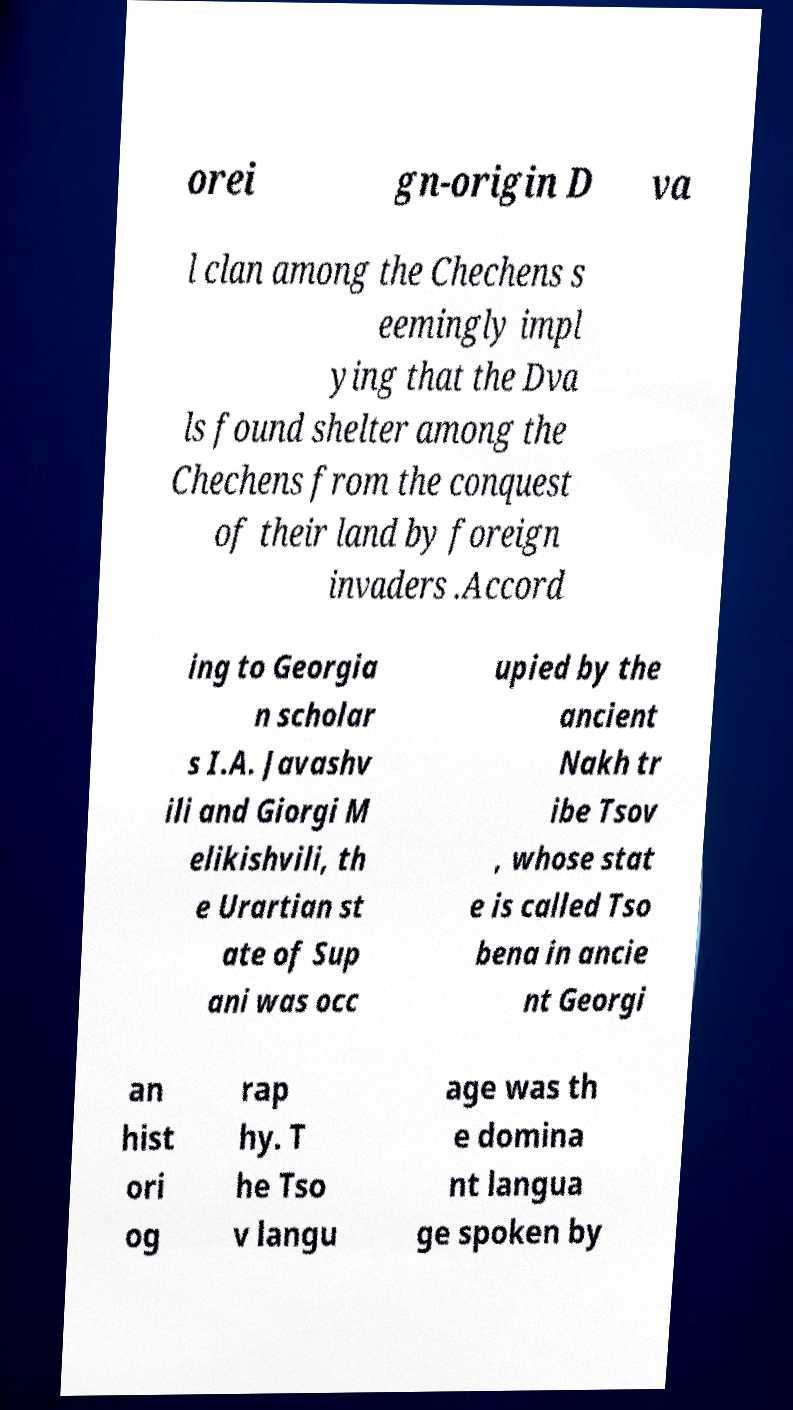Could you extract and type out the text from this image? orei gn-origin D va l clan among the Chechens s eemingly impl ying that the Dva ls found shelter among the Chechens from the conquest of their land by foreign invaders .Accord ing to Georgia n scholar s I.A. Javashv ili and Giorgi M elikishvili, th e Urartian st ate of Sup ani was occ upied by the ancient Nakh tr ibe Tsov , whose stat e is called Tso bena in ancie nt Georgi an hist ori og rap hy. T he Tso v langu age was th e domina nt langua ge spoken by 